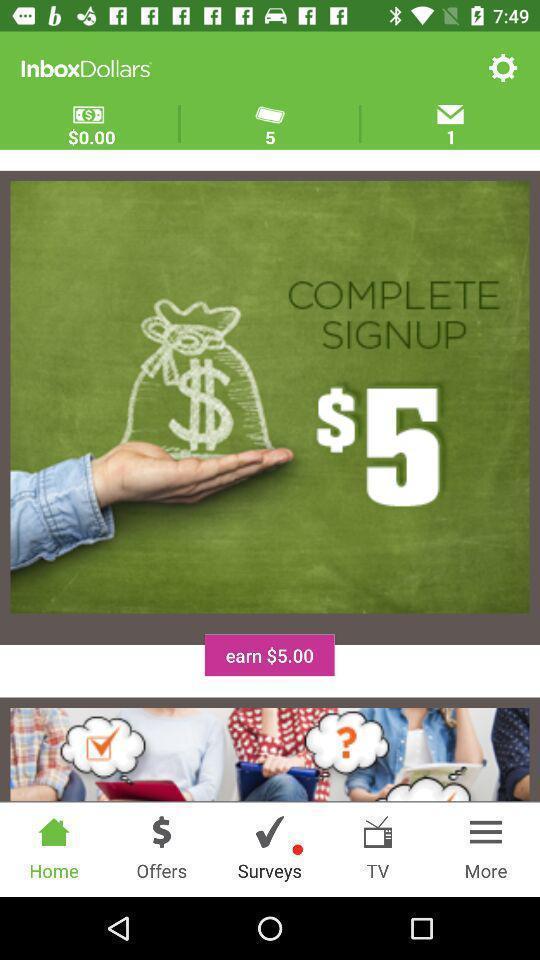Explain what's happening in this screen capture. Screen page displaying various options in financial application. 